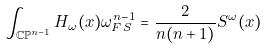<formula> <loc_0><loc_0><loc_500><loc_500>\int _ { \mathbb { C P } ^ { n - 1 } } H _ { \omega } ( x ) \omega _ { F S } ^ { n - 1 } = \frac { 2 } { n ( n + 1 ) } S ^ { \omega } ( x )</formula> 